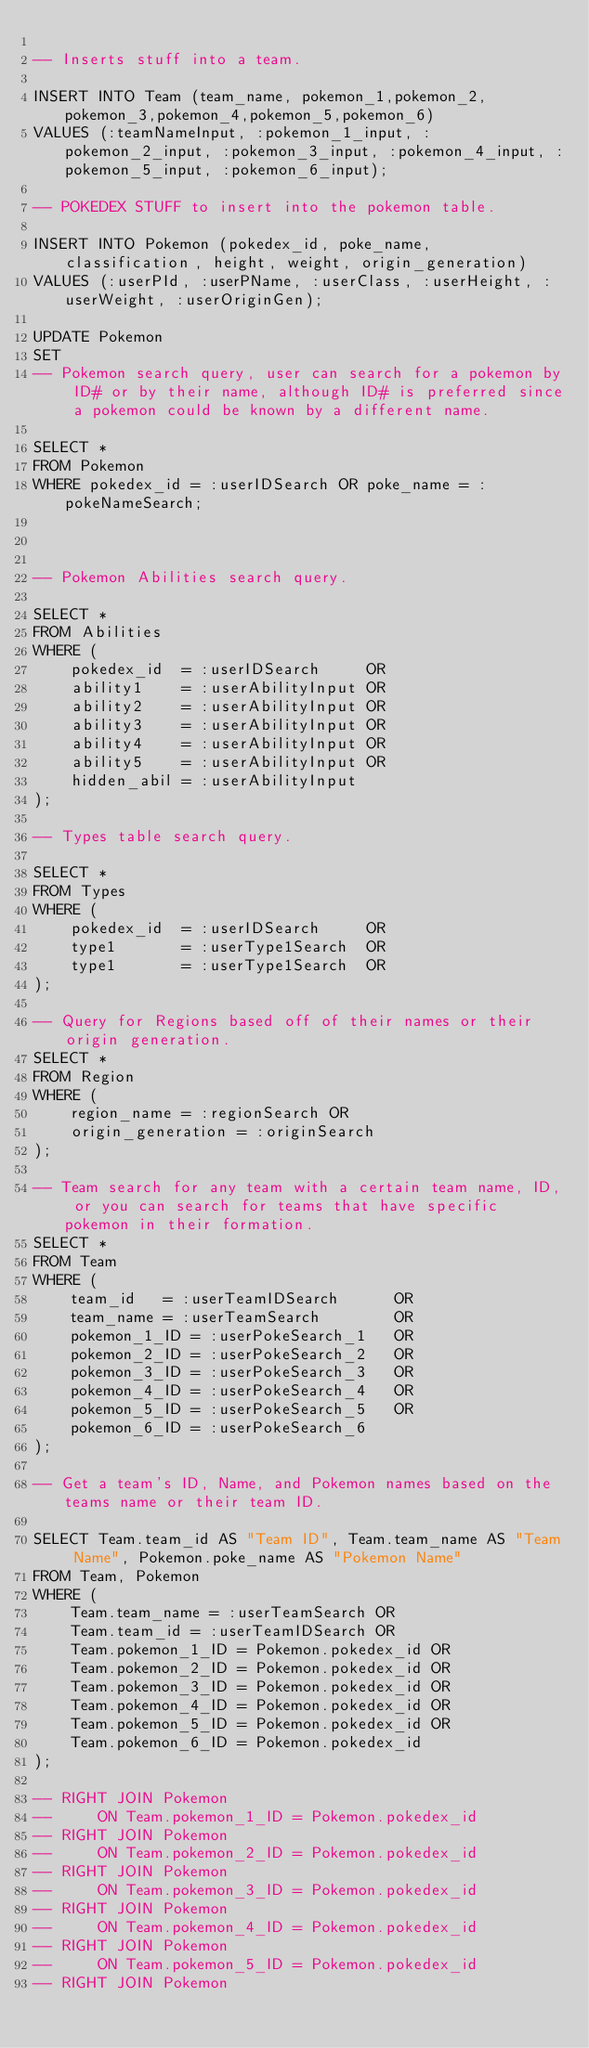Convert code to text. <code><loc_0><loc_0><loc_500><loc_500><_SQL_>
-- Inserts stuff into a team.

INSERT INTO Team (team_name, pokemon_1,pokemon_2,pokemon_3,pokemon_4,pokemon_5,pokemon_6)
VALUES (:teamNameInput, :pokemon_1_input, :pokemon_2_input, :pokemon_3_input, :pokemon_4_input, :pokemon_5_input, :pokemon_6_input);

-- POKEDEX STUFF to insert into the pokemon table.

INSERT INTO Pokemon (pokedex_id, poke_name, classification, height, weight, origin_generation)
VALUES (:userPId, :userPName, :userClass, :userHeight, :userWeight, :userOriginGen);

UPDATE Pokemon
SET 
-- Pokemon search query, user can search for a pokemon by ID# or by their name, although ID# is preferred since a pokemon could be known by a different name.

SELECT * 
FROM Pokemon 
WHERE pokedex_id = :userIDSearch OR poke_name = :pokeNameSearch;



-- Pokemon Abilities search query.

SELECT *
FROM Abilities
WHERE (
    pokedex_id  = :userIDSearch     OR
    ability1    = :userAbilityInput OR
    ability2    = :userAbilityInput OR
    ability3    = :userAbilityInput OR
    ability4    = :userAbilityInput OR
    ability5    = :userAbilityInput OR
    hidden_abil = :userAbilityInput
); 

-- Types table search query.

SELECT *
FROM Types
WHERE (
    pokedex_id  = :userIDSearch     OR
    type1       = :userType1Search  OR   
    type1       = :userType1Search  OR
);

-- Query for Regions based off of their names or their origin generation.
SELECT *
FROM Region
WHERE (
    region_name = :regionSearch OR
    origin_generation = :originSearch
);

-- Team search for any team with a certain team name, ID, or you can search for teams that have specific pokemon in their formation.
SELECT *
FROM Team
WHERE (
    team_id   = :userTeamIDSearch      OR
    team_name = :userTeamSearch        OR
    pokemon_1_ID = :userPokeSearch_1   OR
    pokemon_2_ID = :userPokeSearch_2   OR
    pokemon_3_ID = :userPokeSearch_3   OR
    pokemon_4_ID = :userPokeSearch_4   OR
    pokemon_5_ID = :userPokeSearch_5   OR
    pokemon_6_ID = :userPokeSearch_6
);

-- Get a team's ID, Name, and Pokemon names based on the teams name or their team ID.

SELECT Team.team_id AS "Team ID", Team.team_name AS "Team Name", Pokemon.poke_name AS "Pokemon Name"
FROM Team, Pokemon
WHERE (
    Team.team_name = :userTeamSearch OR 
    Team.team_id = :userTeamIDSearch OR
    Team.pokemon_1_ID = Pokemon.pokedex_id OR
    Team.pokemon_2_ID = Pokemon.pokedex_id OR
    Team.pokemon_3_ID = Pokemon.pokedex_id OR
    Team.pokemon_4_ID = Pokemon.pokedex_id OR
    Team.pokemon_5_ID = Pokemon.pokedex_id OR
    Team.pokemon_6_ID = Pokemon.pokedex_id
);

-- RIGHT JOIN Pokemon
--     ON Team.pokemon_1_ID = Pokemon.pokedex_id
-- RIGHT JOIN Pokemon
--     ON Team.pokemon_2_ID = Pokemon.pokedex_id
-- RIGHT JOIN Pokemon
--     ON Team.pokemon_3_ID = Pokemon.pokedex_id
-- RIGHT JOIN Pokemon
--     ON Team.pokemon_4_ID = Pokemon.pokedex_id
-- RIGHT JOIN Pokemon
--     ON Team.pokemon_5_ID = Pokemon.pokedex_id
-- RIGHT JOIN Pokemon</code> 